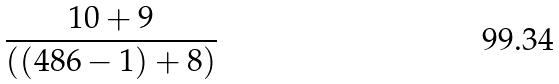Convert formula to latex. <formula><loc_0><loc_0><loc_500><loc_500>\frac { 1 0 + 9 } { ( ( 4 8 6 - 1 ) + 8 ) }</formula> 